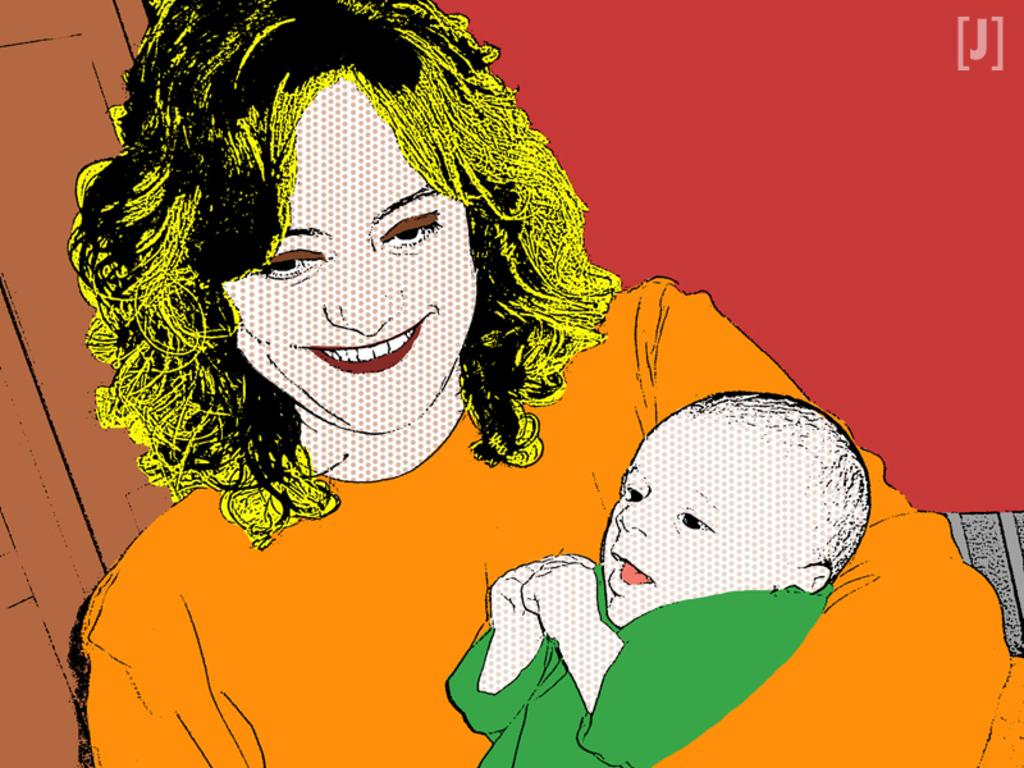What is depicted in the painting in the image? There is a painting of a woman holding a baby in the image. What is the facial expression of the woman in the painting? The woman in the painting has a smile on her face. What architectural feature can be seen on the top left side of the image? There appears to be a door on the top left side of the image. How much money is the woman holding in the painting? The painting does not depict the woman holding any money; she is holding a baby. Can you see any ocean in the image? There is no ocean present in the image. 